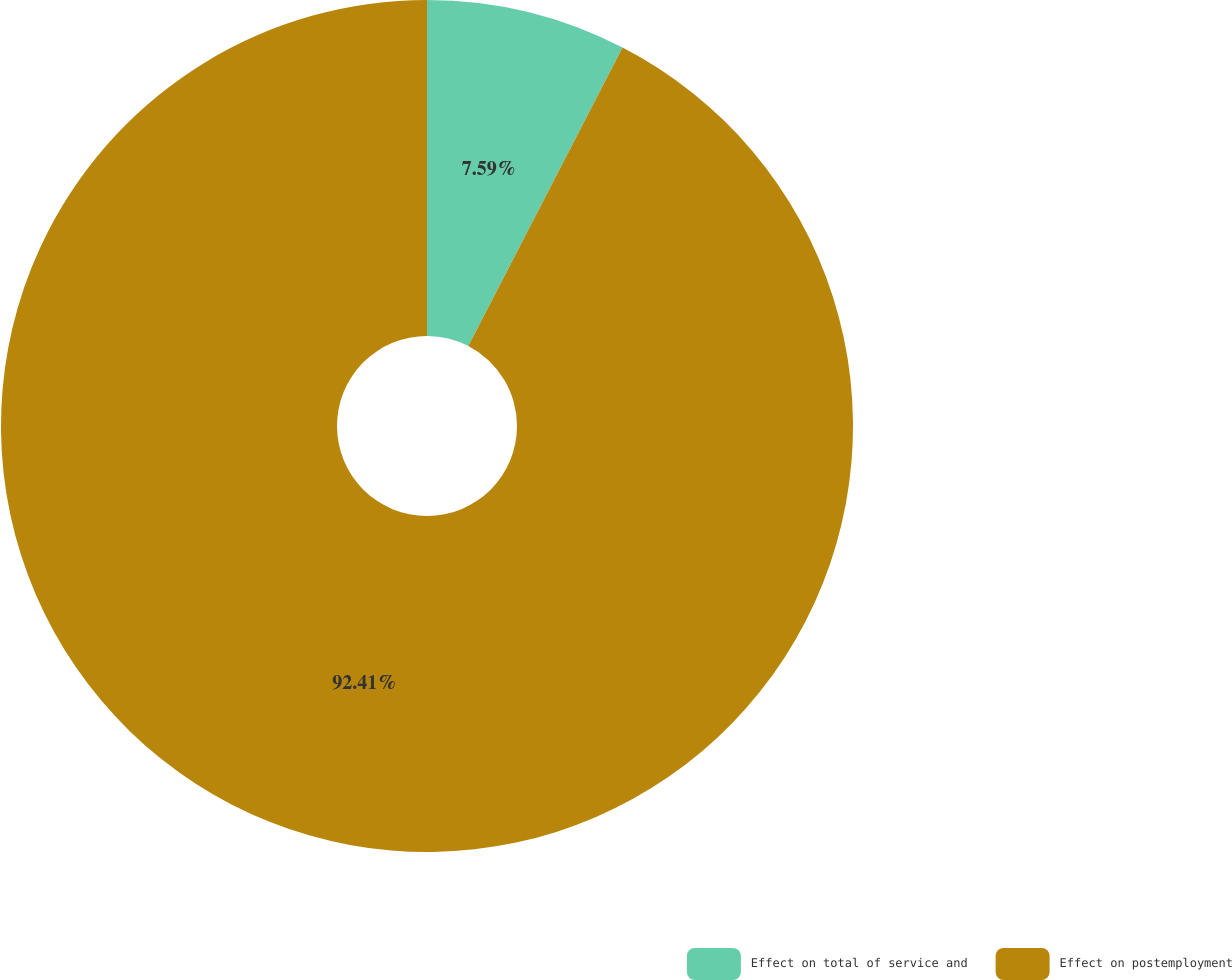Convert chart. <chart><loc_0><loc_0><loc_500><loc_500><pie_chart><fcel>Effect on total of service and<fcel>Effect on postemployment<nl><fcel>7.59%<fcel>92.41%<nl></chart> 